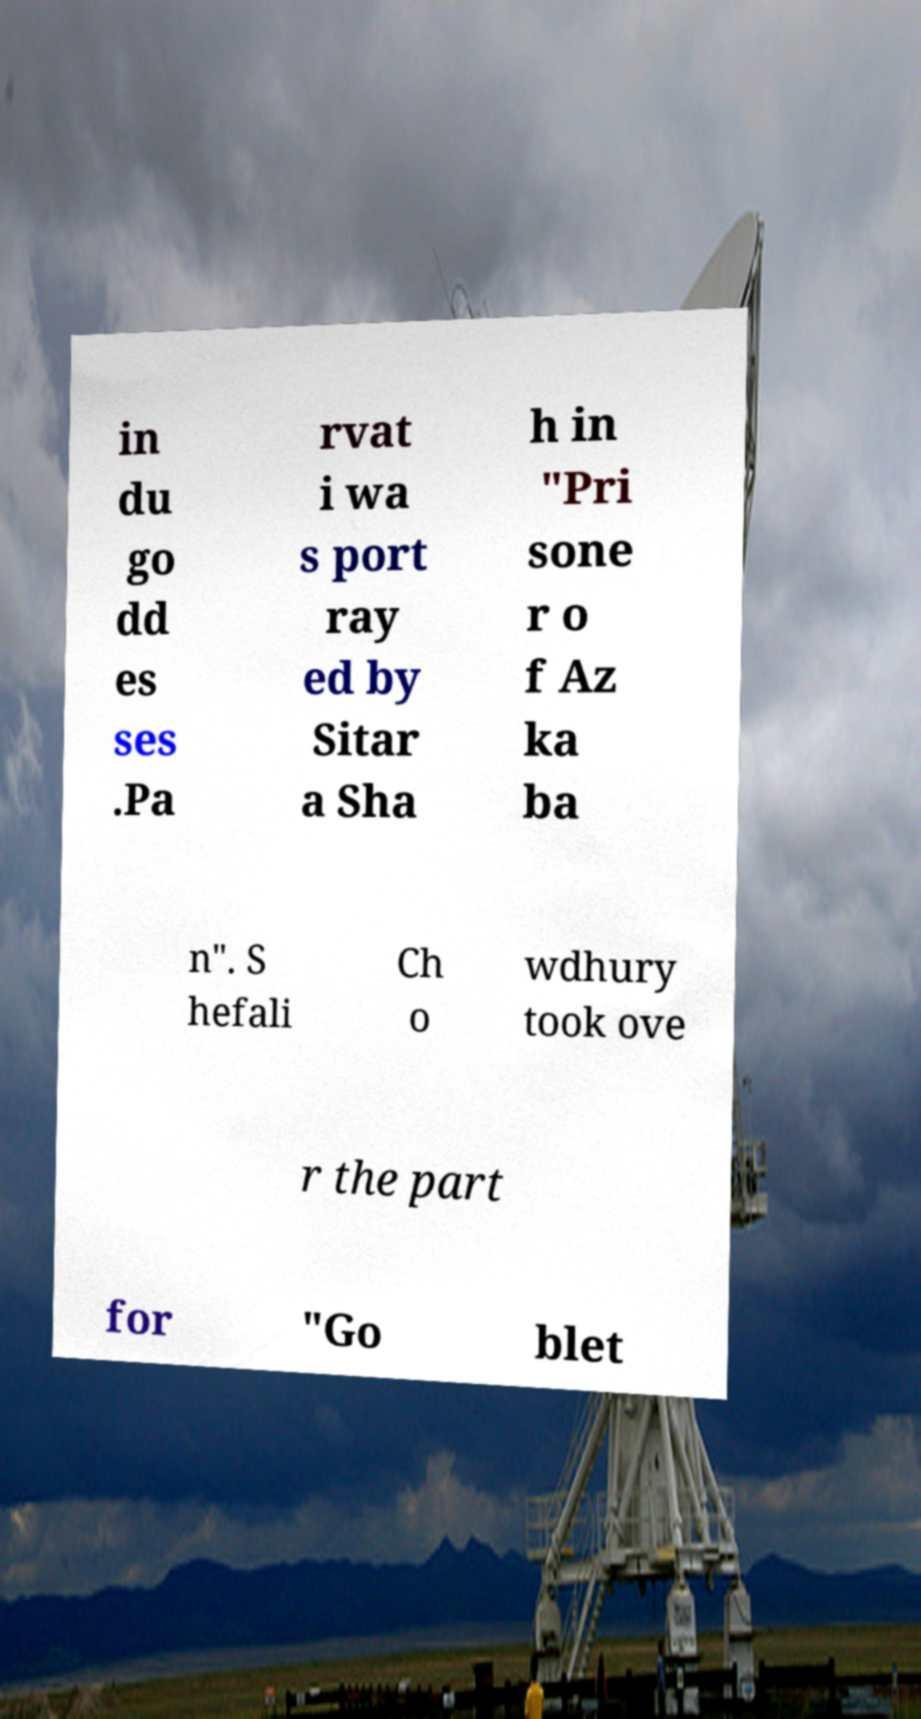There's text embedded in this image that I need extracted. Can you transcribe it verbatim? in du go dd es ses .Pa rvat i wa s port ray ed by Sitar a Sha h in "Pri sone r o f Az ka ba n". S hefali Ch o wdhury took ove r the part for "Go blet 